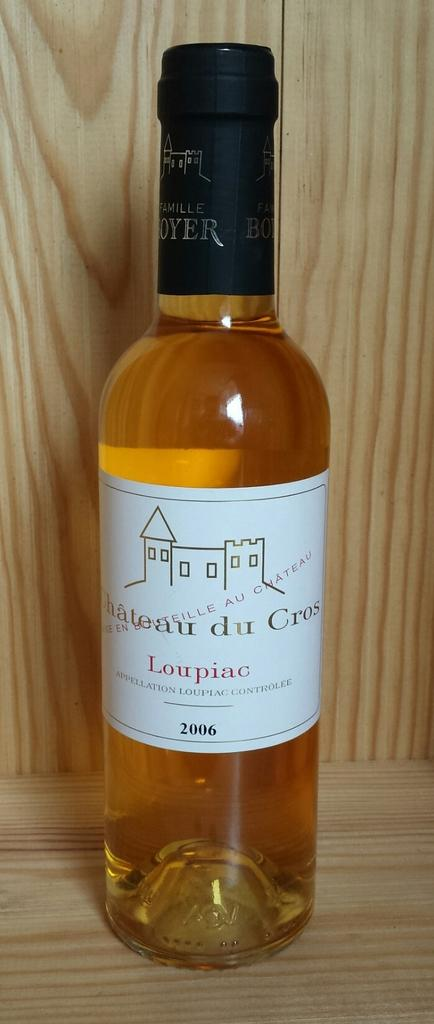Provide a one-sentence caption for the provided image. A bottle of wine with the words Chateau du Cros visible. 